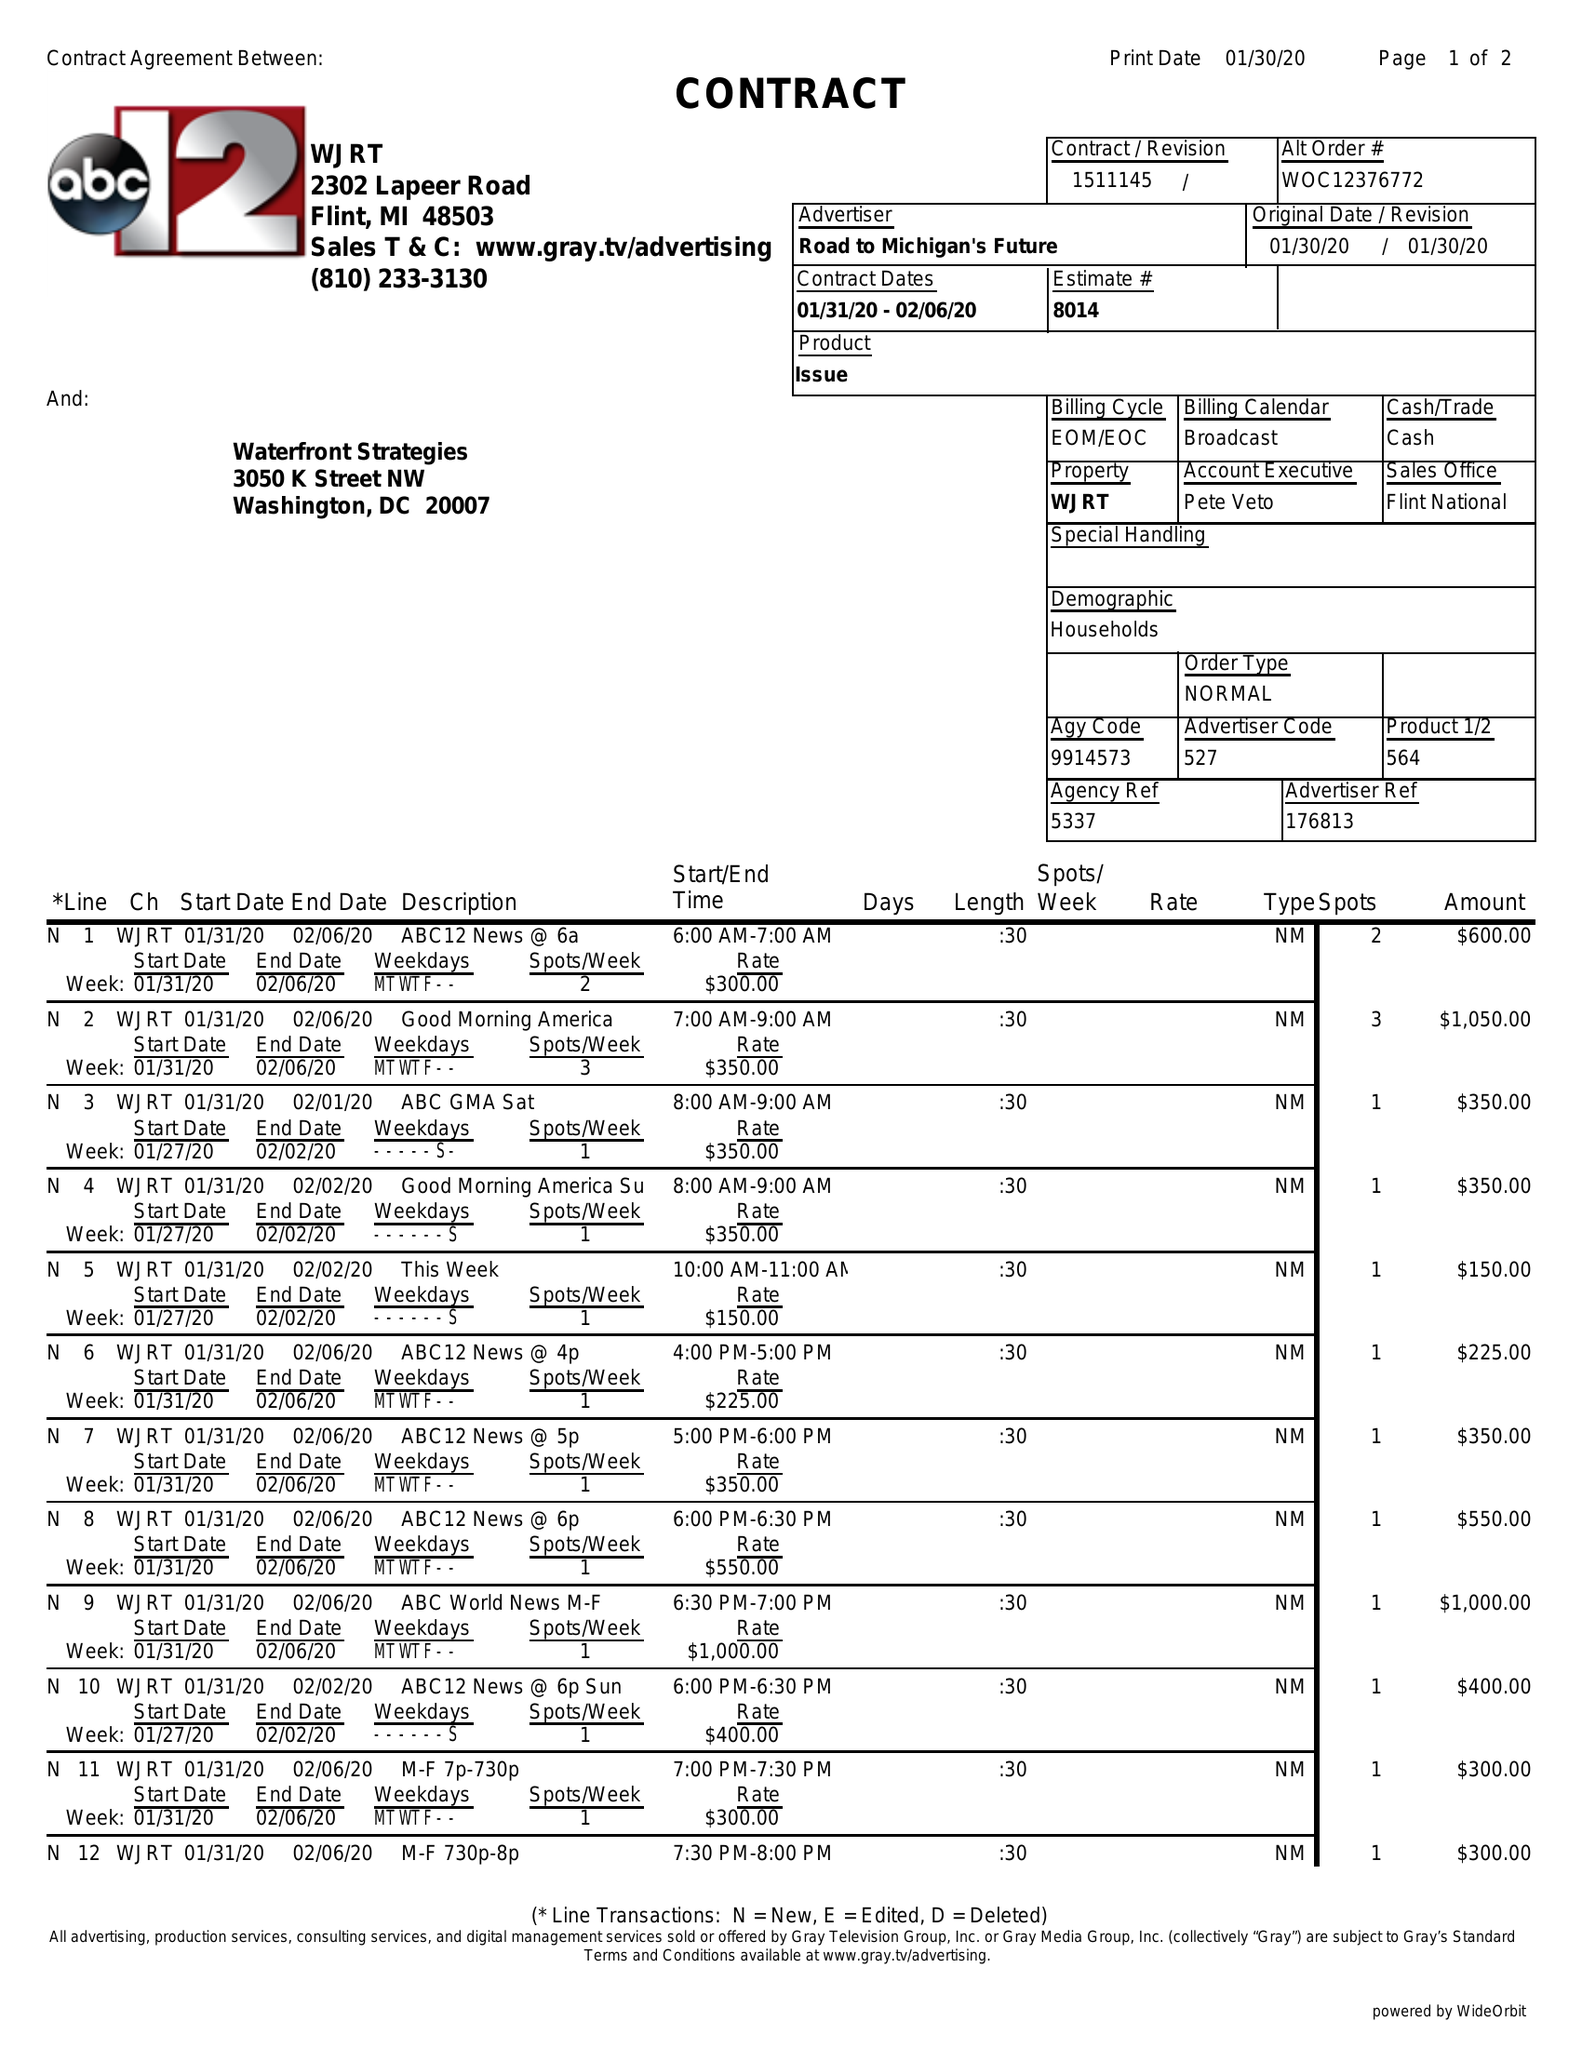What is the value for the advertiser?
Answer the question using a single word or phrase. ROAD TO MICHIGAN'S FUTURE 